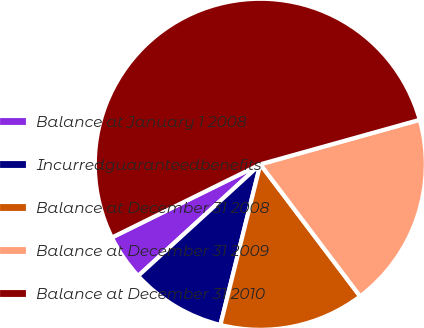<chart> <loc_0><loc_0><loc_500><loc_500><pie_chart><fcel>Balance at January 1 2008<fcel>Incurredguaranteedbenefits<fcel>Balance at December 31 2008<fcel>Balance at December 31 2009<fcel>Balance at December 31 2010<nl><fcel>4.49%<fcel>9.34%<fcel>14.18%<fcel>19.03%<fcel>52.96%<nl></chart> 